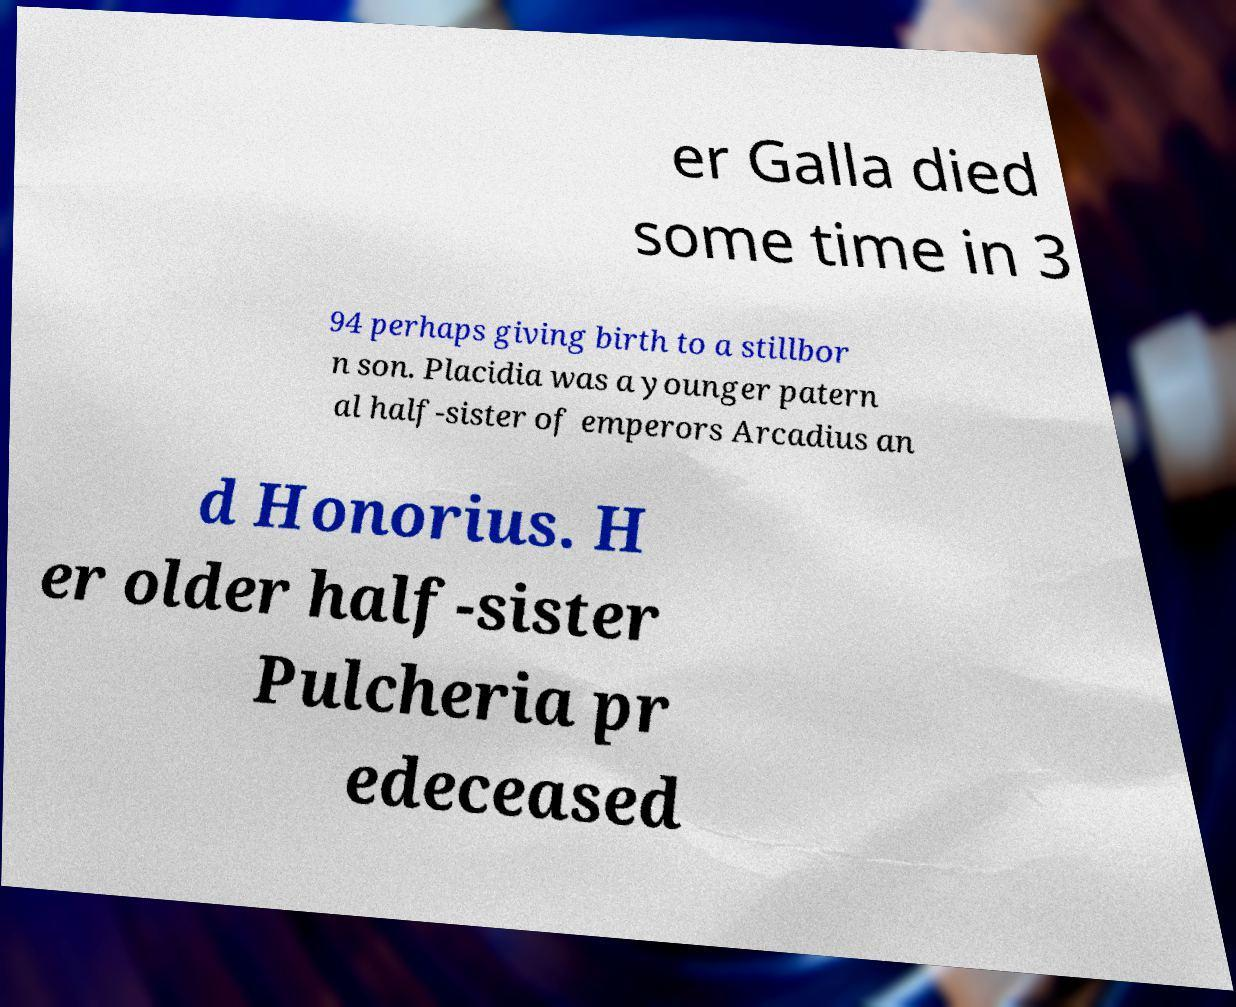There's text embedded in this image that I need extracted. Can you transcribe it verbatim? er Galla died some time in 3 94 perhaps giving birth to a stillbor n son. Placidia was a younger patern al half-sister of emperors Arcadius an d Honorius. H er older half-sister Pulcheria pr edeceased 